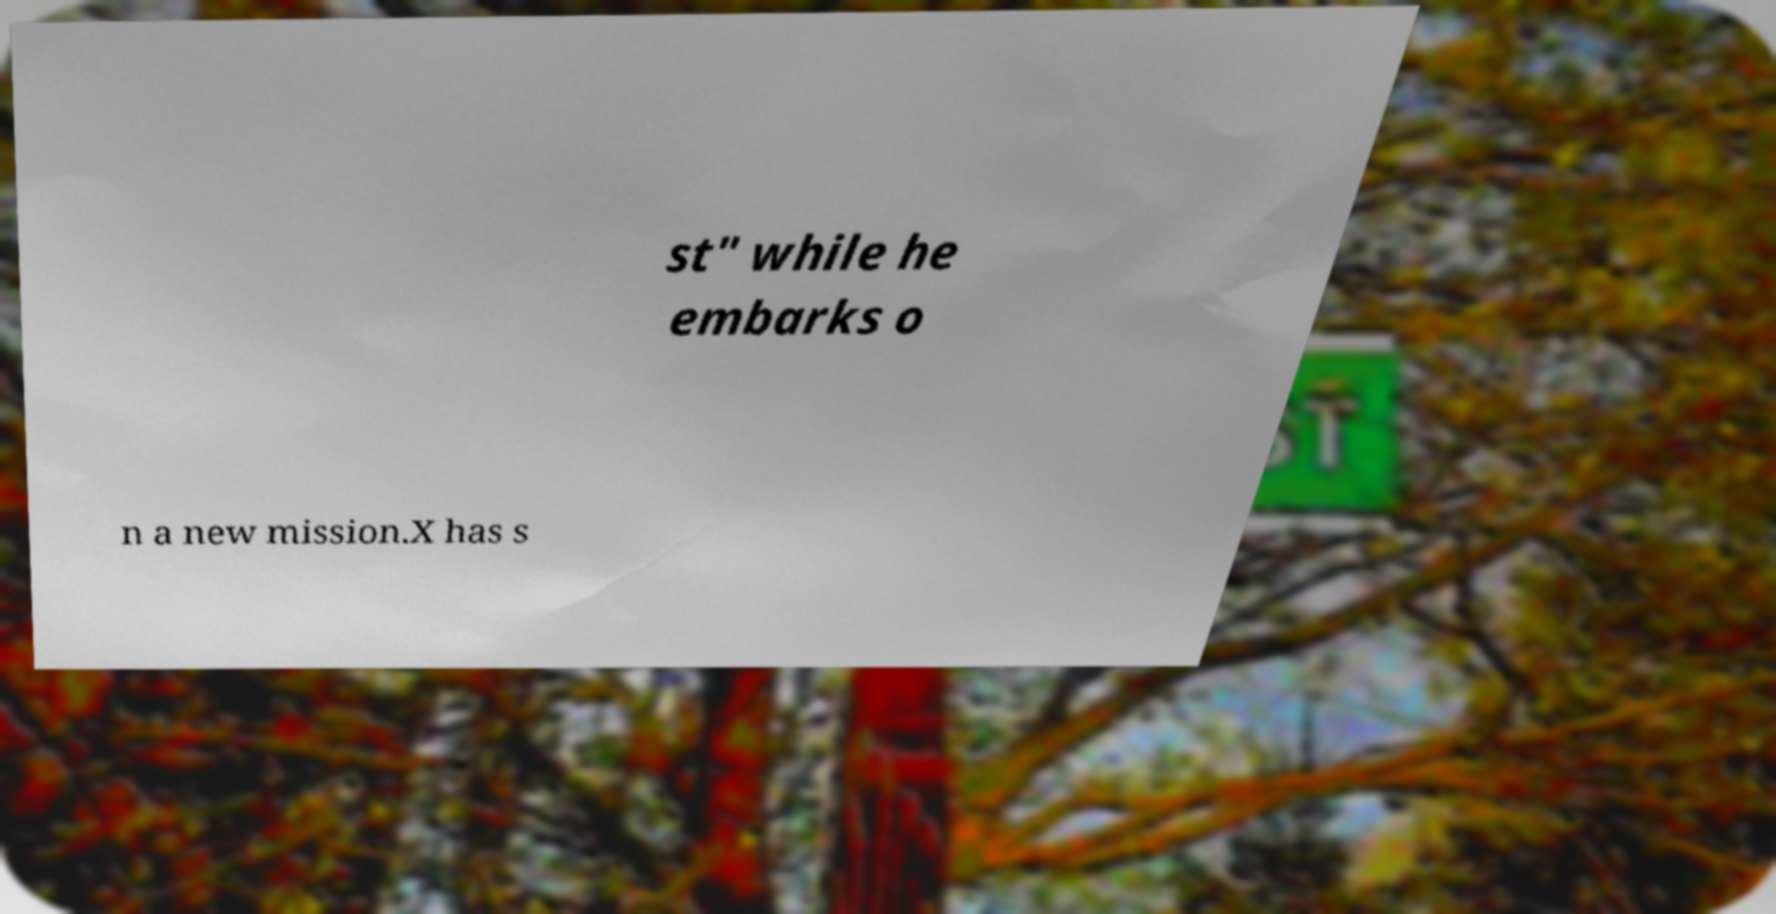Could you extract and type out the text from this image? st" while he embarks o n a new mission.X has s 